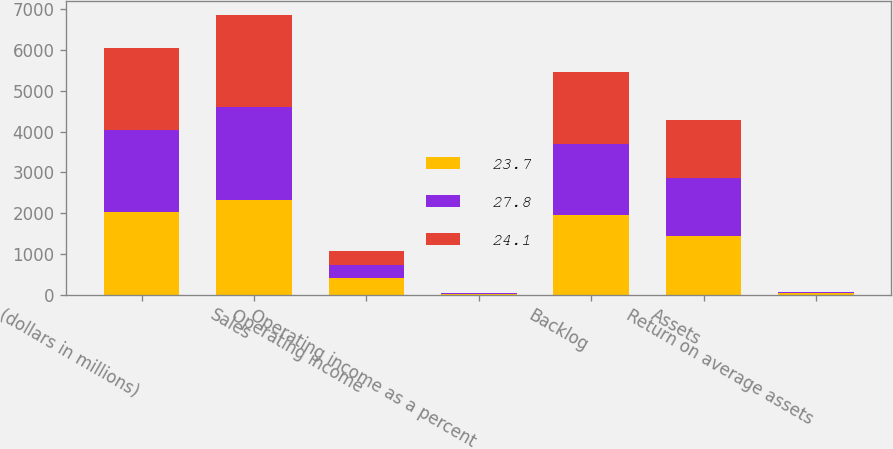Convert chart. <chart><loc_0><loc_0><loc_500><loc_500><stacked_bar_chart><ecel><fcel>(dollars in millions)<fcel>Sales<fcel>Operating income<fcel>Operating income as a percent<fcel>Backlog<fcel>Assets<fcel>Return on average assets<nl><fcel>23.7<fcel>2018<fcel>2316<fcel>398<fcel>17.2<fcel>1954<fcel>1447<fcel>27.8<nl><fcel>27.8<fcel>2017<fcel>2285<fcel>337<fcel>14.8<fcel>1753<fcel>1413<fcel>23.7<nl><fcel>24.1<fcel>2016<fcel>2260<fcel>338<fcel>14.9<fcel>1762<fcel>1431<fcel>24.1<nl></chart> 